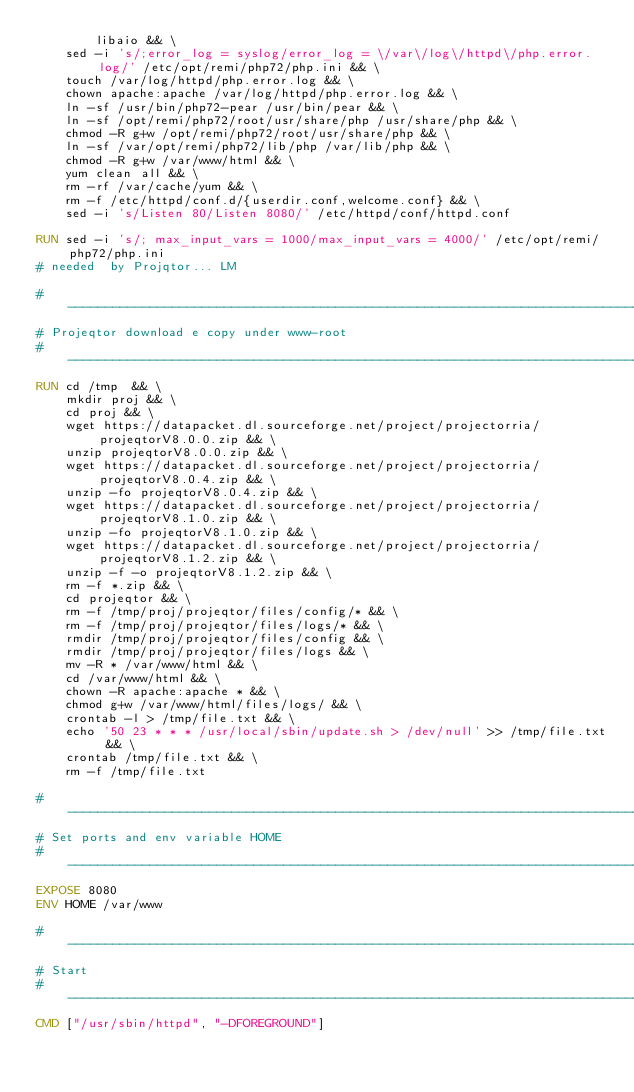<code> <loc_0><loc_0><loc_500><loc_500><_Dockerfile_>        libaio && \
    sed -i 's/;error_log = syslog/error_log = \/var\/log\/httpd\/php.error.log/' /etc/opt/remi/php72/php.ini && \
    touch /var/log/httpd/php.error.log && \
    chown apache:apache /var/log/httpd/php.error.log && \
    ln -sf /usr/bin/php72-pear /usr/bin/pear && \
    ln -sf /opt/remi/php72/root/usr/share/php /usr/share/php && \
    chmod -R g+w /opt/remi/php72/root/usr/share/php && \
    ln -sf /var/opt/remi/php72/lib/php /var/lib/php && \
    chmod -R g+w /var/www/html && \
    yum clean all && \
    rm -rf /var/cache/yum && \
    rm -f /etc/httpd/conf.d/{userdir.conf,welcome.conf} && \
    sed -i 's/Listen 80/Listen 8080/' /etc/httpd/conf/httpd.conf 

RUN sed -i 's/; max_input_vars = 1000/max_input_vars = 4000/' /etc/opt/remi/php72/php.ini
# needed  by Projqtor... LM

# -----------------------------------------------------------------------------
# Projeqtor download e copy under www-root
# -----------------------------------------------------------------------------
RUN cd /tmp  && \
    mkdir proj && \
    cd proj && \
    wget https://datapacket.dl.sourceforge.net/project/projectorria/projeqtorV8.0.0.zip && \
    unzip projeqtorV8.0.0.zip && \
    wget https://datapacket.dl.sourceforge.net/project/projectorria/projeqtorV8.0.4.zip && \
    unzip -fo projeqtorV8.0.4.zip && \
    wget https://datapacket.dl.sourceforge.net/project/projectorria/projeqtorV8.1.0.zip && \
    unzip -fo projeqtorV8.1.0.zip && \
    wget https://datapacket.dl.sourceforge.net/project/projectorria/projeqtorV8.1.2.zip && \
    unzip -f -o projeqtorV8.1.2.zip && \
    rm -f *.zip && \
    cd projeqtor && \
    rm -f /tmp/proj/projeqtor/files/config/* && \
    rm -f /tmp/proj/projeqtor/files/logs/* && \
    rmdir /tmp/proj/projeqtor/files/config && \
    rmdir /tmp/proj/projeqtor/files/logs && \
    mv -R * /var/www/html && \
    cd /var/www/html && \
    chown -R apache:apache * && \
    chmod g+w /var/www/html/files/logs/ && \
    crontab -l > /tmp/file.txt && \
    echo '50 23 * * * /usr/local/sbin/update.sh > /dev/null' >> /tmp/file.txt && \
    crontab /tmp/file.txt && \
    rm -f /tmp/file.txt
    
# -----------------------------------------------------------------------------
# Set ports and env variable HOME
# -----------------------------------------------------------------------------
EXPOSE 8080
ENV HOME /var/www

# -----------------------------------------------------------------------------
# Start
# -----------------------------------------------------------------------------
CMD ["/usr/sbin/httpd", "-DFOREGROUND"]

</code> 